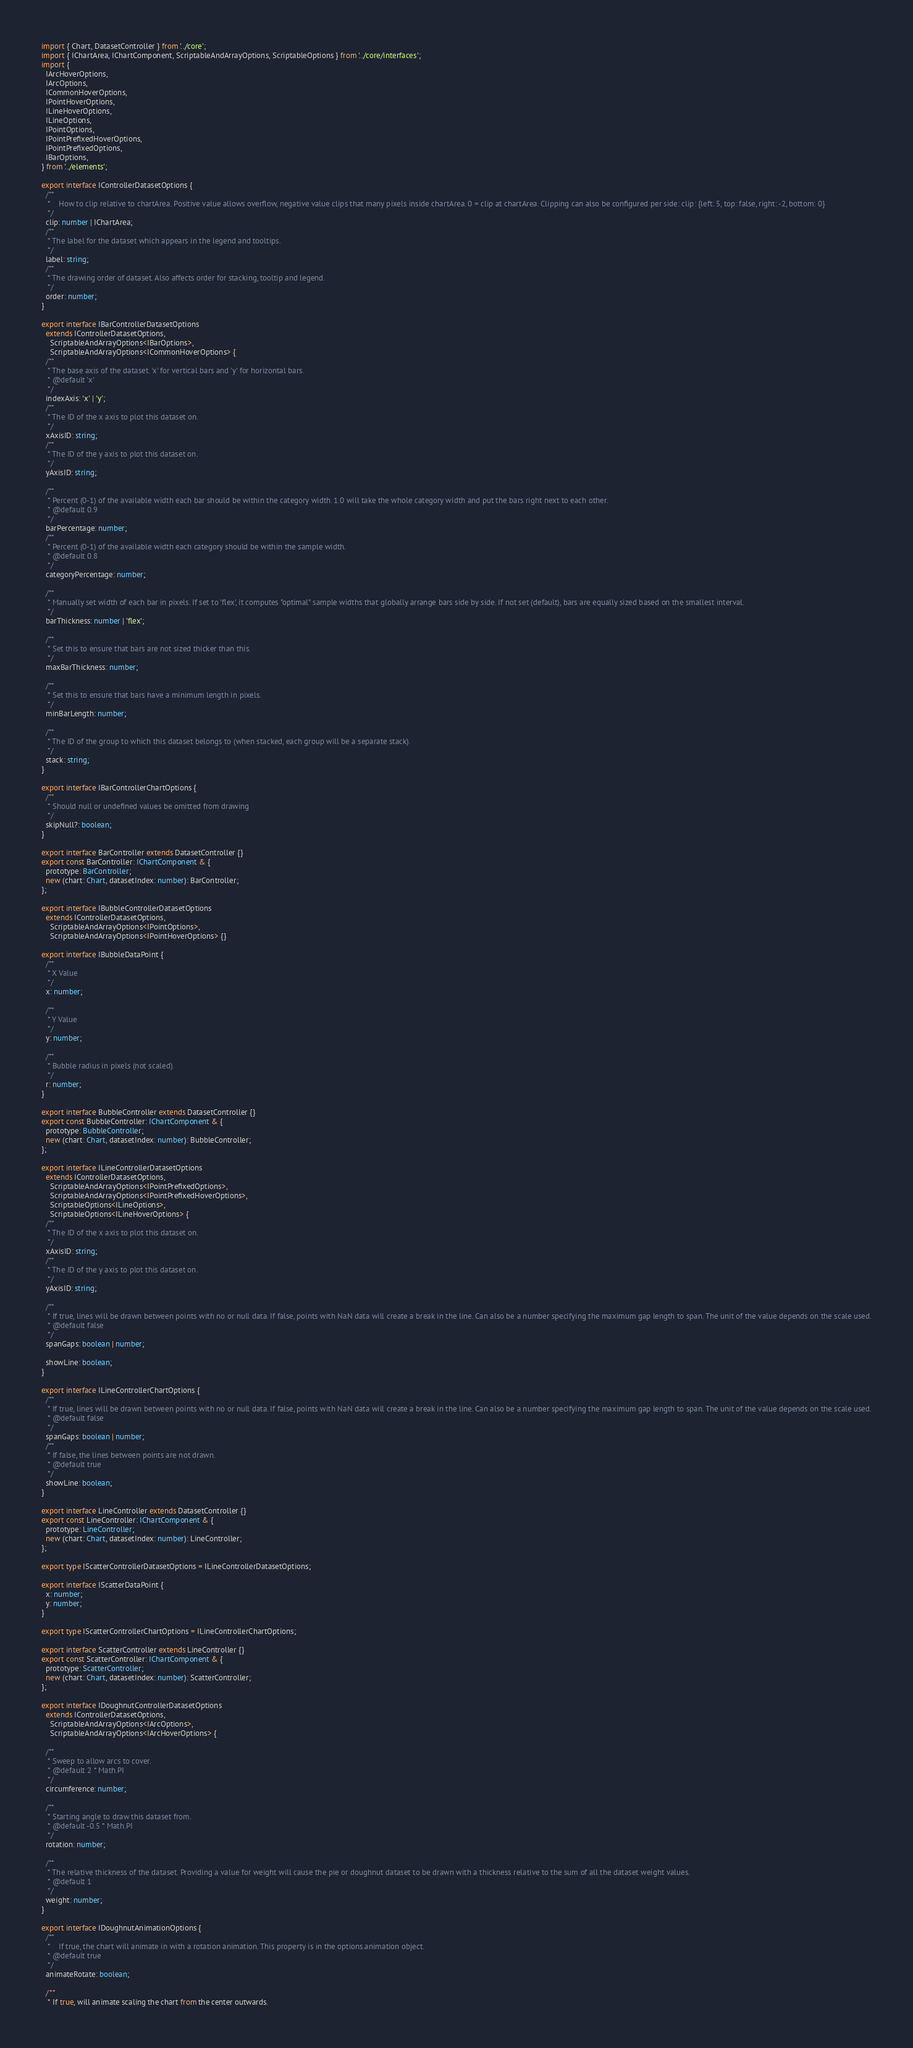<code> <loc_0><loc_0><loc_500><loc_500><_TypeScript_>import { Chart, DatasetController } from '../core';
import { IChartArea, IChartComponent, ScriptableAndArrayOptions, ScriptableOptions } from '../core/interfaces';
import {
  IArcHoverOptions,
  IArcOptions,
  ICommonHoverOptions,
  IPointHoverOptions,
  ILineHoverOptions,
  ILineOptions,
  IPointOptions,
  IPointPrefixedHoverOptions,
  IPointPrefixedOptions,
  IBarOptions,
} from '../elements';

export interface IControllerDatasetOptions {
  /**
   * 	How to clip relative to chartArea. Positive value allows overflow, negative value clips that many pixels inside chartArea. 0 = clip at chartArea. Clipping can also be configured per side: clip: {left: 5, top: false, right: -2, bottom: 0}
   */
  clip: number | IChartArea;
  /**
   * The label for the dataset which appears in the legend and tooltips.
   */
  label: string;
  /**
   * The drawing order of dataset. Also affects order for stacking, tooltip and legend.
   */
  order: number;
}

export interface IBarControllerDatasetOptions
  extends IControllerDatasetOptions,
    ScriptableAndArrayOptions<IBarOptions>,
    ScriptableAndArrayOptions<ICommonHoverOptions> {
  /**
   * The base axis of the dataset. 'x' for vertical bars and 'y' for horizontal bars.
   * @default 'x'
   */
  indexAxis: 'x' | 'y';
  /**
   * The ID of the x axis to plot this dataset on.
   */
  xAxisID: string;
  /**
   * The ID of the y axis to plot this dataset on.
   */
  yAxisID: string;

  /**
   * Percent (0-1) of the available width each bar should be within the category width. 1.0 will take the whole category width and put the bars right next to each other.
   * @default 0.9
   */
  barPercentage: number;
  /**
   * Percent (0-1) of the available width each category should be within the sample width.
   * @default 0.8
   */
  categoryPercentage: number;

  /**
   * Manually set width of each bar in pixels. If set to 'flex', it computes "optimal" sample widths that globally arrange bars side by side. If not set (default), bars are equally sized based on the smallest interval.
   */
  barThickness: number | 'flex';

  /**
   * Set this to ensure that bars are not sized thicker than this.
   */
  maxBarThickness: number;

  /**
   * Set this to ensure that bars have a minimum length in pixels.
   */
  minBarLength: number;

  /**
   * The ID of the group to which this dataset belongs to (when stacked, each group will be a separate stack).
   */
  stack: string;
}

export interface IBarControllerChartOptions {
  /**
   * Should null or undefined values be omitted from drawing
   */
  skipNull?: boolean;
}

export interface BarController extends DatasetController {}
export const BarController: IChartComponent & {
  prototype: BarController;
  new (chart: Chart, datasetIndex: number): BarController;
};

export interface IBubbleControllerDatasetOptions
  extends IControllerDatasetOptions,
    ScriptableAndArrayOptions<IPointOptions>,
    ScriptableAndArrayOptions<IPointHoverOptions> {}

export interface IBubbleDataPoint {
  /**
   * X Value
   */
  x: number;

  /**
   * Y Value
   */
  y: number;

  /**
   * Bubble radius in pixels (not scaled).
   */
  r: number;
}

export interface BubbleController extends DatasetController {}
export const BubbleController: IChartComponent & {
  prototype: BubbleController;
  new (chart: Chart, datasetIndex: number): BubbleController;
};

export interface ILineControllerDatasetOptions
  extends IControllerDatasetOptions,
    ScriptableAndArrayOptions<IPointPrefixedOptions>,
    ScriptableAndArrayOptions<IPointPrefixedHoverOptions>,
    ScriptableOptions<ILineOptions>,
    ScriptableOptions<ILineHoverOptions> {
  /**
   * The ID of the x axis to plot this dataset on.
   */
  xAxisID: string;
  /**
   * The ID of the y axis to plot this dataset on.
   */
  yAxisID: string;

  /**
   * If true, lines will be drawn between points with no or null data. If false, points with NaN data will create a break in the line. Can also be a number specifying the maximum gap length to span. The unit of the value depends on the scale used.
   * @default false
   */
  spanGaps: boolean | number;

  showLine: boolean;
}

export interface ILineControllerChartOptions {
  /**
   * If true, lines will be drawn between points with no or null data. If false, points with NaN data will create a break in the line. Can also be a number specifying the maximum gap length to span. The unit of the value depends on the scale used.
   * @default false
   */
  spanGaps: boolean | number;
  /**
   * If false, the lines between points are not drawn.
   * @default true
   */
  showLine: boolean;
}

export interface LineController extends DatasetController {}
export const LineController: IChartComponent & {
  prototype: LineController;
  new (chart: Chart, datasetIndex: number): LineController;
};

export type IScatterControllerDatasetOptions = ILineControllerDatasetOptions;

export interface IScatterDataPoint {
  x: number;
  y: number;
}

export type IScatterControllerChartOptions = ILineControllerChartOptions;

export interface ScatterController extends LineController {}
export const ScatterController: IChartComponent & {
  prototype: ScatterController;
  new (chart: Chart, datasetIndex: number): ScatterController;
};

export interface IDoughnutControllerDatasetOptions
  extends IControllerDatasetOptions,
    ScriptableAndArrayOptions<IArcOptions>,
    ScriptableAndArrayOptions<IArcHoverOptions> {

  /**
   * Sweep to allow arcs to cover.
   * @default 2 * Math.PI
   */
  circumference: number;

  /**
   * Starting angle to draw this dataset from.
   * @default -0.5 * Math.PI
   */
  rotation: number;

  /**
   * The relative thickness of the dataset. Providing a value for weight will cause the pie or doughnut dataset to be drawn with a thickness relative to the sum of all the dataset weight values.
   * @default 1
   */
  weight: number;
}

export interface IDoughnutAnimationOptions {
  /**
   * 	If true, the chart will animate in with a rotation animation. This property is in the options.animation object.
   * @default true
   */
  animateRotate: boolean;

  /**
   * If true, will animate scaling the chart from the center outwards.</code> 